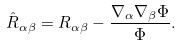Convert formula to latex. <formula><loc_0><loc_0><loc_500><loc_500>\hat { R } _ { \alpha \beta } = { R } _ { \alpha \beta } - \frac { \nabla _ { \alpha } \nabla _ { \beta } \Phi } { \Phi } .</formula> 